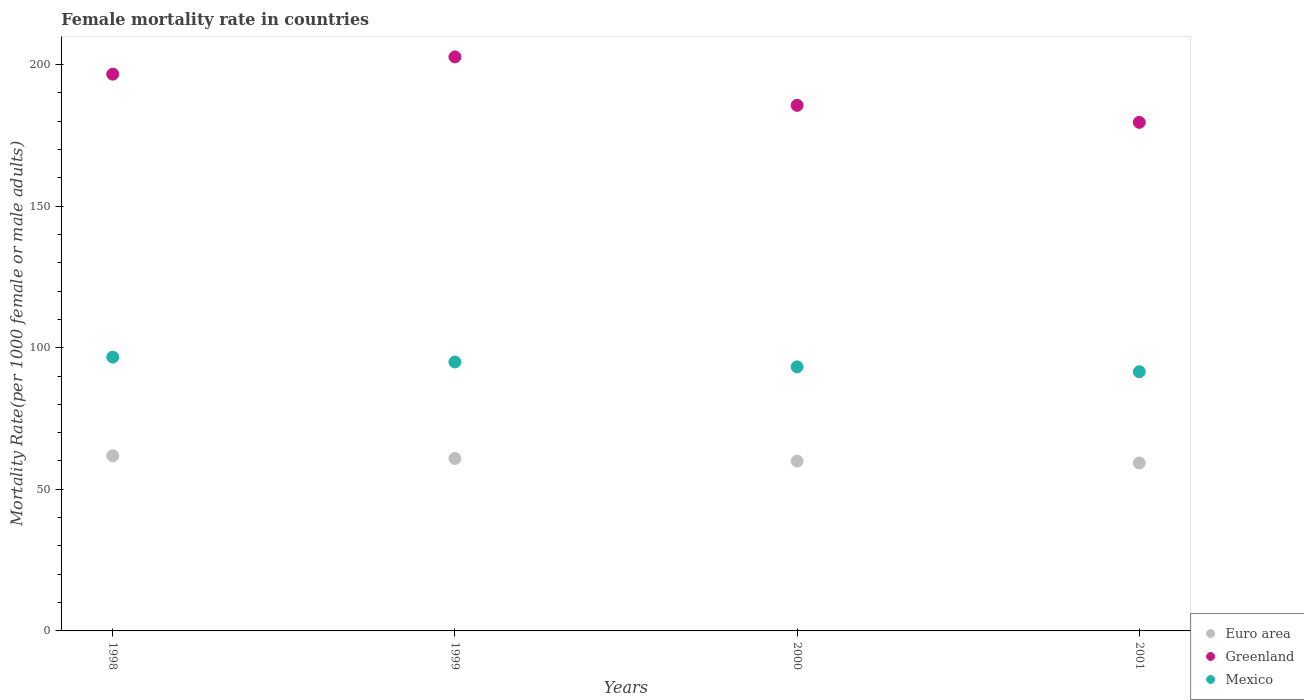What is the female mortality rate in Euro area in 1998?
Provide a short and direct response. 61.85. Across all years, what is the maximum female mortality rate in Greenland?
Your answer should be compact. 202.68. Across all years, what is the minimum female mortality rate in Greenland?
Your answer should be very brief. 179.57. What is the total female mortality rate in Euro area in the graph?
Keep it short and to the point. 241.99. What is the difference between the female mortality rate in Mexico in 1998 and that in 2001?
Offer a terse response. 5.16. What is the difference between the female mortality rate in Mexico in 1998 and the female mortality rate in Euro area in 2000?
Offer a terse response. 36.7. What is the average female mortality rate in Euro area per year?
Provide a short and direct response. 60.5. In the year 2001, what is the difference between the female mortality rate in Greenland and female mortality rate in Euro area?
Offer a very short reply. 120.27. What is the ratio of the female mortality rate in Greenland in 1998 to that in 2000?
Your answer should be very brief. 1.06. Is the difference between the female mortality rate in Greenland in 2000 and 2001 greater than the difference between the female mortality rate in Euro area in 2000 and 2001?
Your answer should be compact. Yes. What is the difference between the highest and the second highest female mortality rate in Greenland?
Ensure brevity in your answer.  6.1. What is the difference between the highest and the lowest female mortality rate in Greenland?
Your response must be concise. 23.11. In how many years, is the female mortality rate in Mexico greater than the average female mortality rate in Mexico taken over all years?
Offer a very short reply. 2. Is it the case that in every year, the sum of the female mortality rate in Euro area and female mortality rate in Greenland  is greater than the female mortality rate in Mexico?
Your answer should be compact. Yes. Does the graph contain grids?
Your answer should be very brief. No. Where does the legend appear in the graph?
Give a very brief answer. Bottom right. How many legend labels are there?
Ensure brevity in your answer.  3. How are the legend labels stacked?
Provide a succinct answer. Vertical. What is the title of the graph?
Your answer should be compact. Female mortality rate in countries. What is the label or title of the Y-axis?
Offer a very short reply. Mortality Rate(per 1000 female or male adults). What is the Mortality Rate(per 1000 female or male adults) in Euro area in 1998?
Ensure brevity in your answer.  61.85. What is the Mortality Rate(per 1000 female or male adults) in Greenland in 1998?
Give a very brief answer. 196.58. What is the Mortality Rate(per 1000 female or male adults) in Mexico in 1998?
Provide a succinct answer. 96.67. What is the Mortality Rate(per 1000 female or male adults) in Euro area in 1999?
Your answer should be very brief. 60.88. What is the Mortality Rate(per 1000 female or male adults) in Greenland in 1999?
Provide a short and direct response. 202.68. What is the Mortality Rate(per 1000 female or male adults) of Mexico in 1999?
Ensure brevity in your answer.  94.95. What is the Mortality Rate(per 1000 female or male adults) of Euro area in 2000?
Ensure brevity in your answer.  59.97. What is the Mortality Rate(per 1000 female or male adults) of Greenland in 2000?
Give a very brief answer. 185.57. What is the Mortality Rate(per 1000 female or male adults) in Mexico in 2000?
Your answer should be compact. 93.23. What is the Mortality Rate(per 1000 female or male adults) in Euro area in 2001?
Offer a very short reply. 59.29. What is the Mortality Rate(per 1000 female or male adults) of Greenland in 2001?
Your response must be concise. 179.57. What is the Mortality Rate(per 1000 female or male adults) of Mexico in 2001?
Ensure brevity in your answer.  91.51. Across all years, what is the maximum Mortality Rate(per 1000 female or male adults) in Euro area?
Your response must be concise. 61.85. Across all years, what is the maximum Mortality Rate(per 1000 female or male adults) of Greenland?
Offer a very short reply. 202.68. Across all years, what is the maximum Mortality Rate(per 1000 female or male adults) in Mexico?
Offer a terse response. 96.67. Across all years, what is the minimum Mortality Rate(per 1000 female or male adults) of Euro area?
Make the answer very short. 59.29. Across all years, what is the minimum Mortality Rate(per 1000 female or male adults) in Greenland?
Keep it short and to the point. 179.57. Across all years, what is the minimum Mortality Rate(per 1000 female or male adults) of Mexico?
Provide a short and direct response. 91.51. What is the total Mortality Rate(per 1000 female or male adults) of Euro area in the graph?
Your response must be concise. 241.99. What is the total Mortality Rate(per 1000 female or male adults) of Greenland in the graph?
Offer a very short reply. 764.39. What is the total Mortality Rate(per 1000 female or male adults) in Mexico in the graph?
Make the answer very short. 376.36. What is the difference between the Mortality Rate(per 1000 female or male adults) of Euro area in 1998 and that in 1999?
Your response must be concise. 0.96. What is the difference between the Mortality Rate(per 1000 female or male adults) of Greenland in 1998 and that in 1999?
Your answer should be very brief. -6.1. What is the difference between the Mortality Rate(per 1000 female or male adults) in Mexico in 1998 and that in 1999?
Provide a succinct answer. 1.72. What is the difference between the Mortality Rate(per 1000 female or male adults) of Euro area in 1998 and that in 2000?
Give a very brief answer. 1.88. What is the difference between the Mortality Rate(per 1000 female or male adults) in Greenland in 1998 and that in 2000?
Offer a terse response. 11.01. What is the difference between the Mortality Rate(per 1000 female or male adults) of Mexico in 1998 and that in 2000?
Provide a succinct answer. 3.44. What is the difference between the Mortality Rate(per 1000 female or male adults) in Euro area in 1998 and that in 2001?
Keep it short and to the point. 2.55. What is the difference between the Mortality Rate(per 1000 female or male adults) in Greenland in 1998 and that in 2001?
Your answer should be very brief. 17.02. What is the difference between the Mortality Rate(per 1000 female or male adults) in Mexico in 1998 and that in 2001?
Provide a short and direct response. 5.16. What is the difference between the Mortality Rate(per 1000 female or male adults) of Euro area in 1999 and that in 2000?
Offer a terse response. 0.91. What is the difference between the Mortality Rate(per 1000 female or male adults) in Greenland in 1999 and that in 2000?
Give a very brief answer. 17.11. What is the difference between the Mortality Rate(per 1000 female or male adults) of Mexico in 1999 and that in 2000?
Offer a very short reply. 1.72. What is the difference between the Mortality Rate(per 1000 female or male adults) of Euro area in 1999 and that in 2001?
Ensure brevity in your answer.  1.59. What is the difference between the Mortality Rate(per 1000 female or male adults) in Greenland in 1999 and that in 2001?
Offer a very short reply. 23.11. What is the difference between the Mortality Rate(per 1000 female or male adults) of Mexico in 1999 and that in 2001?
Keep it short and to the point. 3.44. What is the difference between the Mortality Rate(per 1000 female or male adults) in Euro area in 2000 and that in 2001?
Offer a very short reply. 0.68. What is the difference between the Mortality Rate(per 1000 female or male adults) in Greenland in 2000 and that in 2001?
Keep it short and to the point. 6. What is the difference between the Mortality Rate(per 1000 female or male adults) in Mexico in 2000 and that in 2001?
Provide a short and direct response. 1.72. What is the difference between the Mortality Rate(per 1000 female or male adults) in Euro area in 1998 and the Mortality Rate(per 1000 female or male adults) in Greenland in 1999?
Your answer should be very brief. -140.84. What is the difference between the Mortality Rate(per 1000 female or male adults) of Euro area in 1998 and the Mortality Rate(per 1000 female or male adults) of Mexico in 1999?
Keep it short and to the point. -33.1. What is the difference between the Mortality Rate(per 1000 female or male adults) of Greenland in 1998 and the Mortality Rate(per 1000 female or male adults) of Mexico in 1999?
Ensure brevity in your answer.  101.63. What is the difference between the Mortality Rate(per 1000 female or male adults) in Euro area in 1998 and the Mortality Rate(per 1000 female or male adults) in Greenland in 2000?
Provide a succinct answer. -123.72. What is the difference between the Mortality Rate(per 1000 female or male adults) of Euro area in 1998 and the Mortality Rate(per 1000 female or male adults) of Mexico in 2000?
Ensure brevity in your answer.  -31.39. What is the difference between the Mortality Rate(per 1000 female or male adults) of Greenland in 1998 and the Mortality Rate(per 1000 female or male adults) of Mexico in 2000?
Provide a succinct answer. 103.35. What is the difference between the Mortality Rate(per 1000 female or male adults) in Euro area in 1998 and the Mortality Rate(per 1000 female or male adults) in Greenland in 2001?
Your answer should be compact. -117.72. What is the difference between the Mortality Rate(per 1000 female or male adults) of Euro area in 1998 and the Mortality Rate(per 1000 female or male adults) of Mexico in 2001?
Provide a short and direct response. -29.67. What is the difference between the Mortality Rate(per 1000 female or male adults) of Greenland in 1998 and the Mortality Rate(per 1000 female or male adults) of Mexico in 2001?
Your answer should be very brief. 105.07. What is the difference between the Mortality Rate(per 1000 female or male adults) in Euro area in 1999 and the Mortality Rate(per 1000 female or male adults) in Greenland in 2000?
Your answer should be compact. -124.68. What is the difference between the Mortality Rate(per 1000 female or male adults) of Euro area in 1999 and the Mortality Rate(per 1000 female or male adults) of Mexico in 2000?
Make the answer very short. -32.35. What is the difference between the Mortality Rate(per 1000 female or male adults) in Greenland in 1999 and the Mortality Rate(per 1000 female or male adults) in Mexico in 2000?
Offer a terse response. 109.45. What is the difference between the Mortality Rate(per 1000 female or male adults) in Euro area in 1999 and the Mortality Rate(per 1000 female or male adults) in Greenland in 2001?
Your response must be concise. -118.68. What is the difference between the Mortality Rate(per 1000 female or male adults) in Euro area in 1999 and the Mortality Rate(per 1000 female or male adults) in Mexico in 2001?
Your answer should be compact. -30.63. What is the difference between the Mortality Rate(per 1000 female or male adults) in Greenland in 1999 and the Mortality Rate(per 1000 female or male adults) in Mexico in 2001?
Ensure brevity in your answer.  111.17. What is the difference between the Mortality Rate(per 1000 female or male adults) in Euro area in 2000 and the Mortality Rate(per 1000 female or male adults) in Greenland in 2001?
Give a very brief answer. -119.6. What is the difference between the Mortality Rate(per 1000 female or male adults) of Euro area in 2000 and the Mortality Rate(per 1000 female or male adults) of Mexico in 2001?
Make the answer very short. -31.54. What is the difference between the Mortality Rate(per 1000 female or male adults) of Greenland in 2000 and the Mortality Rate(per 1000 female or male adults) of Mexico in 2001?
Your response must be concise. 94.06. What is the average Mortality Rate(per 1000 female or male adults) of Euro area per year?
Keep it short and to the point. 60.5. What is the average Mortality Rate(per 1000 female or male adults) in Greenland per year?
Your answer should be compact. 191.1. What is the average Mortality Rate(per 1000 female or male adults) of Mexico per year?
Provide a short and direct response. 94.09. In the year 1998, what is the difference between the Mortality Rate(per 1000 female or male adults) of Euro area and Mortality Rate(per 1000 female or male adults) of Greenland?
Your response must be concise. -134.74. In the year 1998, what is the difference between the Mortality Rate(per 1000 female or male adults) in Euro area and Mortality Rate(per 1000 female or male adults) in Mexico?
Your response must be concise. -34.82. In the year 1998, what is the difference between the Mortality Rate(per 1000 female or male adults) of Greenland and Mortality Rate(per 1000 female or male adults) of Mexico?
Your response must be concise. 99.91. In the year 1999, what is the difference between the Mortality Rate(per 1000 female or male adults) of Euro area and Mortality Rate(per 1000 female or male adults) of Greenland?
Provide a succinct answer. -141.8. In the year 1999, what is the difference between the Mortality Rate(per 1000 female or male adults) of Euro area and Mortality Rate(per 1000 female or male adults) of Mexico?
Ensure brevity in your answer.  -34.07. In the year 1999, what is the difference between the Mortality Rate(per 1000 female or male adults) in Greenland and Mortality Rate(per 1000 female or male adults) in Mexico?
Offer a terse response. 107.73. In the year 2000, what is the difference between the Mortality Rate(per 1000 female or male adults) of Euro area and Mortality Rate(per 1000 female or male adults) of Greenland?
Your answer should be compact. -125.6. In the year 2000, what is the difference between the Mortality Rate(per 1000 female or male adults) in Euro area and Mortality Rate(per 1000 female or male adults) in Mexico?
Offer a terse response. -33.26. In the year 2000, what is the difference between the Mortality Rate(per 1000 female or male adults) of Greenland and Mortality Rate(per 1000 female or male adults) of Mexico?
Give a very brief answer. 92.34. In the year 2001, what is the difference between the Mortality Rate(per 1000 female or male adults) in Euro area and Mortality Rate(per 1000 female or male adults) in Greenland?
Your answer should be compact. -120.27. In the year 2001, what is the difference between the Mortality Rate(per 1000 female or male adults) of Euro area and Mortality Rate(per 1000 female or male adults) of Mexico?
Your response must be concise. -32.22. In the year 2001, what is the difference between the Mortality Rate(per 1000 female or male adults) of Greenland and Mortality Rate(per 1000 female or male adults) of Mexico?
Your answer should be compact. 88.05. What is the ratio of the Mortality Rate(per 1000 female or male adults) in Euro area in 1998 to that in 1999?
Offer a very short reply. 1.02. What is the ratio of the Mortality Rate(per 1000 female or male adults) in Greenland in 1998 to that in 1999?
Offer a terse response. 0.97. What is the ratio of the Mortality Rate(per 1000 female or male adults) of Mexico in 1998 to that in 1999?
Your response must be concise. 1.02. What is the ratio of the Mortality Rate(per 1000 female or male adults) of Euro area in 1998 to that in 2000?
Your response must be concise. 1.03. What is the ratio of the Mortality Rate(per 1000 female or male adults) in Greenland in 1998 to that in 2000?
Give a very brief answer. 1.06. What is the ratio of the Mortality Rate(per 1000 female or male adults) of Mexico in 1998 to that in 2000?
Make the answer very short. 1.04. What is the ratio of the Mortality Rate(per 1000 female or male adults) of Euro area in 1998 to that in 2001?
Your response must be concise. 1.04. What is the ratio of the Mortality Rate(per 1000 female or male adults) of Greenland in 1998 to that in 2001?
Ensure brevity in your answer.  1.09. What is the ratio of the Mortality Rate(per 1000 female or male adults) of Mexico in 1998 to that in 2001?
Ensure brevity in your answer.  1.06. What is the ratio of the Mortality Rate(per 1000 female or male adults) of Euro area in 1999 to that in 2000?
Give a very brief answer. 1.02. What is the ratio of the Mortality Rate(per 1000 female or male adults) of Greenland in 1999 to that in 2000?
Make the answer very short. 1.09. What is the ratio of the Mortality Rate(per 1000 female or male adults) of Mexico in 1999 to that in 2000?
Offer a very short reply. 1.02. What is the ratio of the Mortality Rate(per 1000 female or male adults) of Euro area in 1999 to that in 2001?
Give a very brief answer. 1.03. What is the ratio of the Mortality Rate(per 1000 female or male adults) in Greenland in 1999 to that in 2001?
Make the answer very short. 1.13. What is the ratio of the Mortality Rate(per 1000 female or male adults) of Mexico in 1999 to that in 2001?
Ensure brevity in your answer.  1.04. What is the ratio of the Mortality Rate(per 1000 female or male adults) of Euro area in 2000 to that in 2001?
Give a very brief answer. 1.01. What is the ratio of the Mortality Rate(per 1000 female or male adults) of Greenland in 2000 to that in 2001?
Ensure brevity in your answer.  1.03. What is the ratio of the Mortality Rate(per 1000 female or male adults) of Mexico in 2000 to that in 2001?
Provide a short and direct response. 1.02. What is the difference between the highest and the second highest Mortality Rate(per 1000 female or male adults) in Euro area?
Your answer should be very brief. 0.96. What is the difference between the highest and the second highest Mortality Rate(per 1000 female or male adults) in Greenland?
Provide a succinct answer. 6.1. What is the difference between the highest and the second highest Mortality Rate(per 1000 female or male adults) of Mexico?
Give a very brief answer. 1.72. What is the difference between the highest and the lowest Mortality Rate(per 1000 female or male adults) in Euro area?
Provide a short and direct response. 2.55. What is the difference between the highest and the lowest Mortality Rate(per 1000 female or male adults) of Greenland?
Provide a short and direct response. 23.11. What is the difference between the highest and the lowest Mortality Rate(per 1000 female or male adults) of Mexico?
Your answer should be very brief. 5.16. 